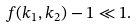<formula> <loc_0><loc_0><loc_500><loc_500>f ( k _ { 1 } , k _ { 2 } ) - 1 \ll 1 .</formula> 